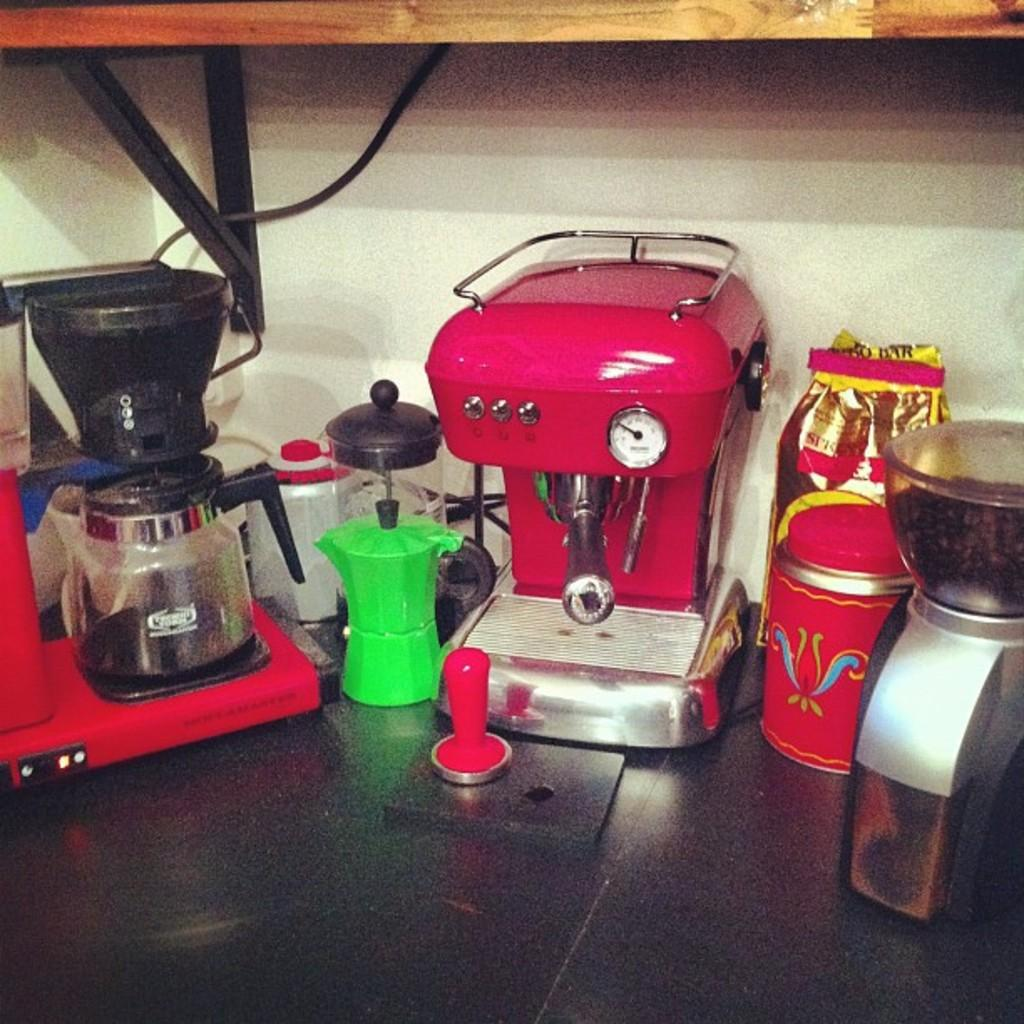What type of appliances are visible in the image? There are coffee makers in the image. What other objects can be seen in the image? There are jugs and a packet visible in the image. Where are these objects placed in the image? The objects are placed on a wooden shelf fixed to the wall in the image. Can you see a bee buzzing around the coffee makers in the image? No, there is no bee present in the image. Is there a basin visible in the image? No, there is no basin present in the image. 